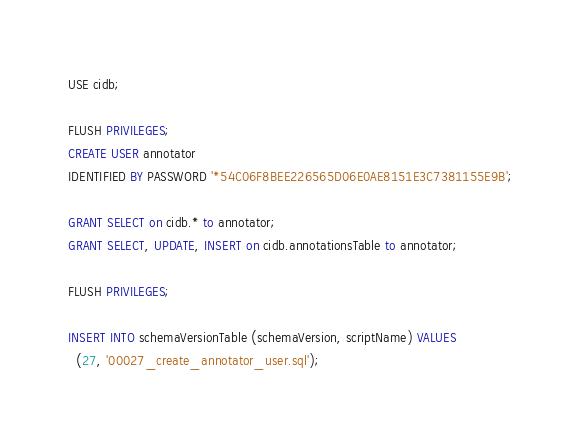Convert code to text. <code><loc_0><loc_0><loc_500><loc_500><_SQL_>USE cidb;

FLUSH PRIVILEGES;
CREATE USER annotator
IDENTIFIED BY PASSWORD '*54C06F8BEE226565D06E0AE8151E3C7381155E9B';

GRANT SELECT on cidb.* to annotator;
GRANT SELECT, UPDATE, INSERT on cidb.annotationsTable to annotator;

FLUSH PRIVILEGES;

INSERT INTO schemaVersionTable (schemaVersion, scriptName) VALUES
  (27, '00027_create_annotator_user.sql');
</code> 